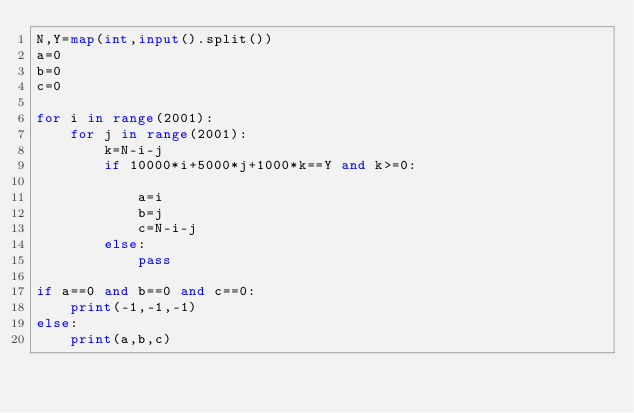Convert code to text. <code><loc_0><loc_0><loc_500><loc_500><_Python_>N,Y=map(int,input().split())
a=0
b=0
c=0

for i in range(2001):
    for j in range(2001):
        k=N-i-j
        if 10000*i+5000*j+1000*k==Y and k>=0:
            
            a=i
            b=j
            c=N-i-j
        else:
            pass

if a==0 and b==0 and c==0:
    print(-1,-1,-1)
else:
    print(a,b,c)
</code> 